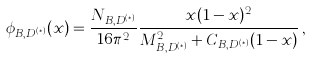<formula> <loc_0><loc_0><loc_500><loc_500>\phi _ { B , D ^ { ( * ) } } ( x ) = \frac { N _ { B , D ^ { ( * ) } } } { 1 6 \pi ^ { 2 } } \frac { x ( 1 - x ) ^ { 2 } } { M _ { B , D ^ { ( * ) } } ^ { 2 } + C _ { B , D ^ { ( * ) } } ( 1 - x ) } \, ,</formula> 